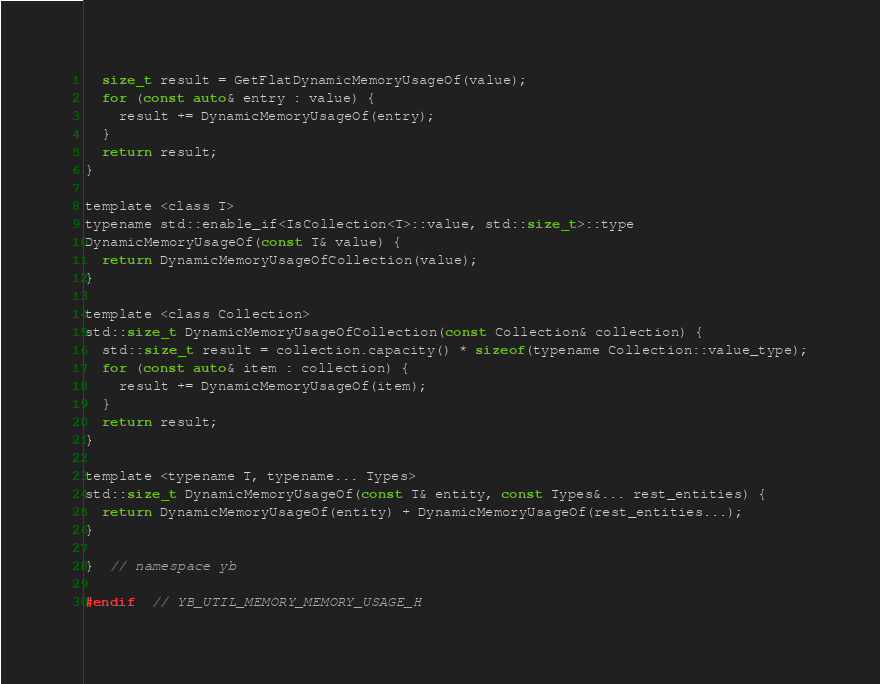<code> <loc_0><loc_0><loc_500><loc_500><_C_>  size_t result = GetFlatDynamicMemoryUsageOf(value);
  for (const auto& entry : value) {
    result += DynamicMemoryUsageOf(entry);
  }
  return result;
}

template <class T>
typename std::enable_if<IsCollection<T>::value, std::size_t>::type
DynamicMemoryUsageOf(const T& value) {
  return DynamicMemoryUsageOfCollection(value);
}

template <class Collection>
std::size_t DynamicMemoryUsageOfCollection(const Collection& collection) {
  std::size_t result = collection.capacity() * sizeof(typename Collection::value_type);
  for (const auto& item : collection) {
    result += DynamicMemoryUsageOf(item);
  }
  return result;
}

template <typename T, typename... Types>
std::size_t DynamicMemoryUsageOf(const T& entity, const Types&... rest_entities) {
  return DynamicMemoryUsageOf(entity) + DynamicMemoryUsageOf(rest_entities...);
}

}  // namespace yb

#endif  // YB_UTIL_MEMORY_MEMORY_USAGE_H
</code> 